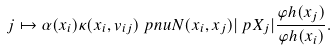<formula> <loc_0><loc_0><loc_500><loc_500>j & \mapsto \alpha ( x _ { i } ) \kappa ( x _ { i } , v _ { i j } ) \ p n u N ( x _ { i } , x _ { j } ) | \ p X _ { j } | \frac { \varphi h ( x _ { j } ) } { \varphi h ( x _ { i } ) } .</formula> 